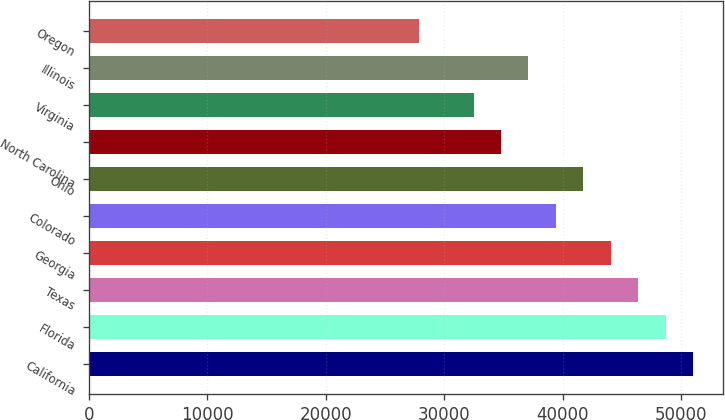<chart> <loc_0><loc_0><loc_500><loc_500><bar_chart><fcel>California<fcel>Florida<fcel>Texas<fcel>Georgia<fcel>Colorado<fcel>Ohio<fcel>North Carolina<fcel>Virginia<fcel>Illinois<fcel>Oregon<nl><fcel>50968<fcel>48654<fcel>46340<fcel>44026<fcel>39398<fcel>41712<fcel>34770<fcel>32456<fcel>37084<fcel>27828<nl></chart> 